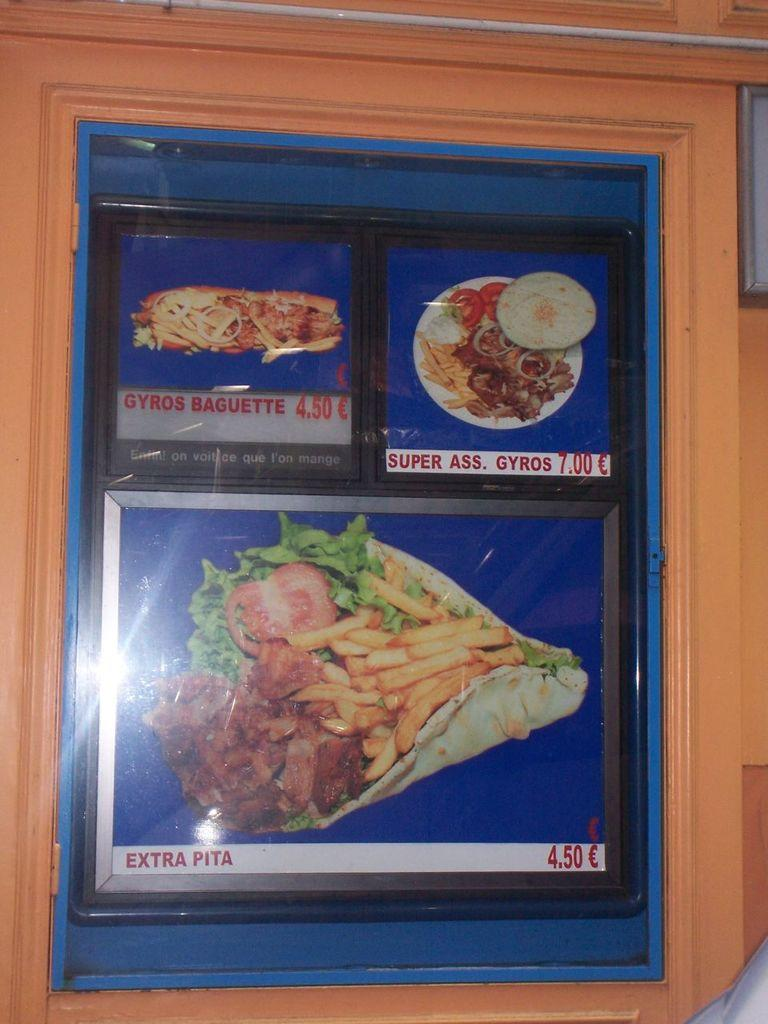What is the main object in the image? There is a wooden board in the image. What is depicted on the wooden board? There are pictures of food items on the wooden board. Are there any words or phrases on the wooden board? Yes, there is text written on the wooden board. How does the wooden board contribute to pollution in the image? The wooden board does not contribute to pollution in the image; it is an inanimate object. 